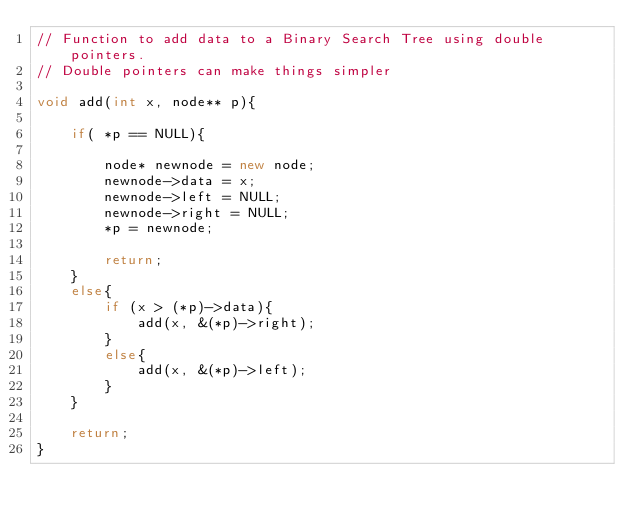<code> <loc_0><loc_0><loc_500><loc_500><_C++_>// Function to add data to a Binary Search Tree using double pointers.
// Double pointers can make things simpler

void add(int x, node** p){

    if( *p == NULL){

        node* newnode = new node;
        newnode->data = x;
        newnode->left = NULL;
        newnode->right = NULL;
        *p = newnode;

        return;
    }
    else{
        if (x > (*p)->data){
            add(x, &(*p)->right);
        }
        else{
            add(x, &(*p)->left);
        }
    }

    return;
}
</code> 